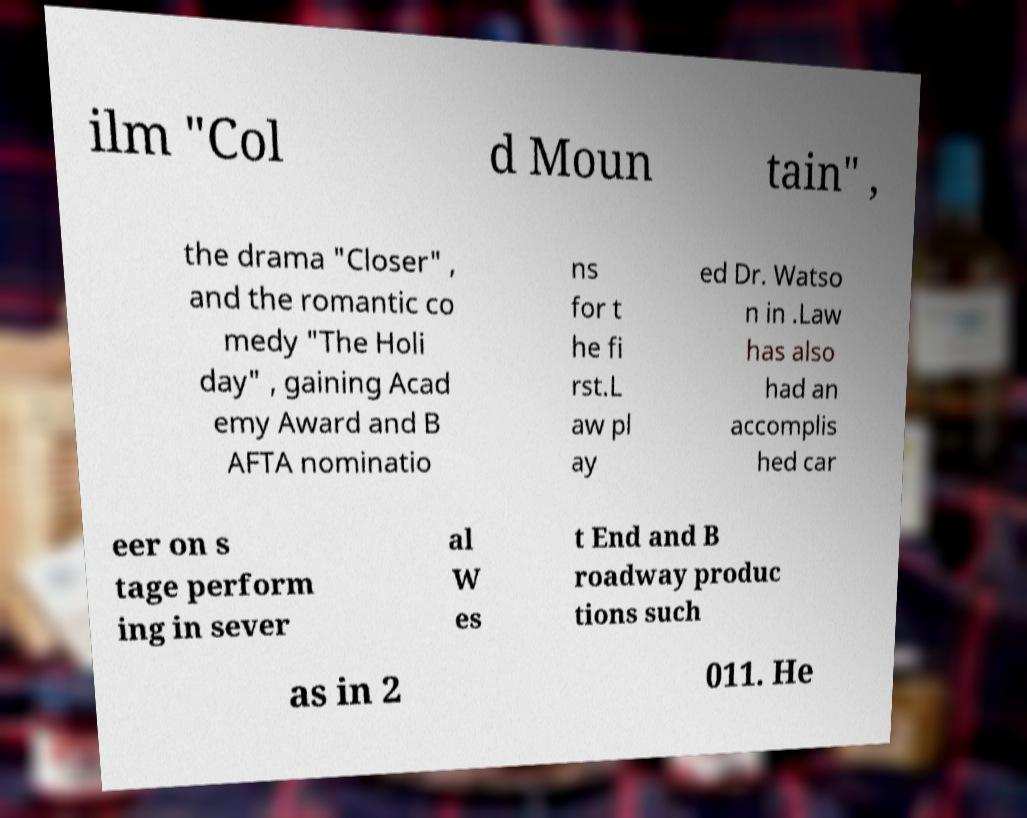For documentation purposes, I need the text within this image transcribed. Could you provide that? ilm "Col d Moun tain" , the drama "Closer" , and the romantic co medy "The Holi day" , gaining Acad emy Award and B AFTA nominatio ns for t he fi rst.L aw pl ay ed Dr. Watso n in .Law has also had an accomplis hed car eer on s tage perform ing in sever al W es t End and B roadway produc tions such as in 2 011. He 